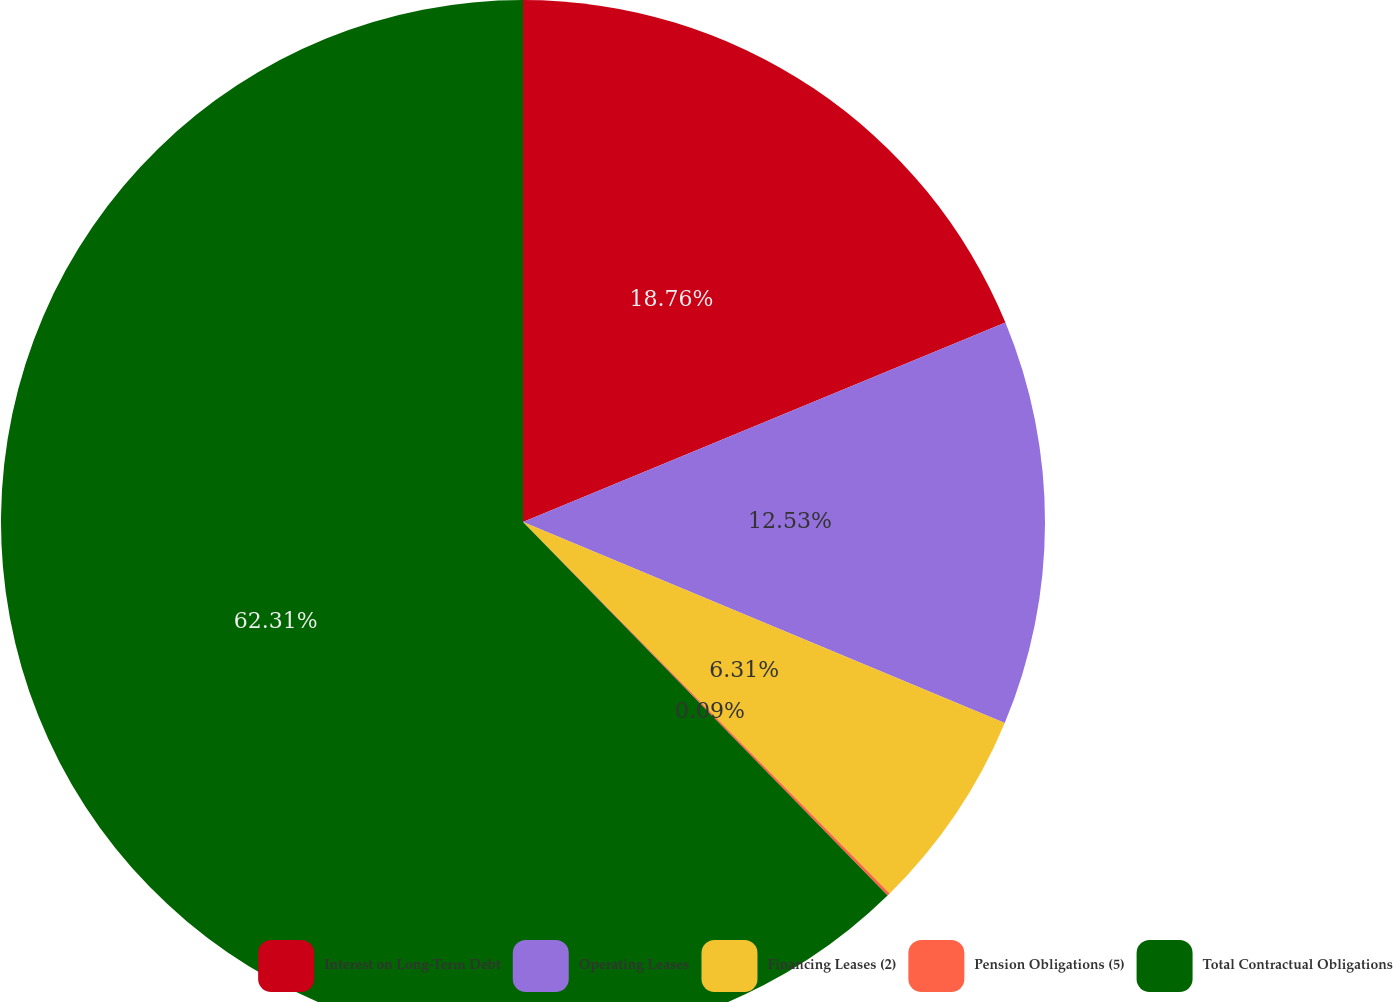Convert chart to OTSL. <chart><loc_0><loc_0><loc_500><loc_500><pie_chart><fcel>Interest on Long-Term Debt<fcel>Operating Leases<fcel>Financing Leases (2)<fcel>Pension Obligations (5)<fcel>Total Contractual Obligations<nl><fcel>18.76%<fcel>12.53%<fcel>6.31%<fcel>0.09%<fcel>62.3%<nl></chart> 